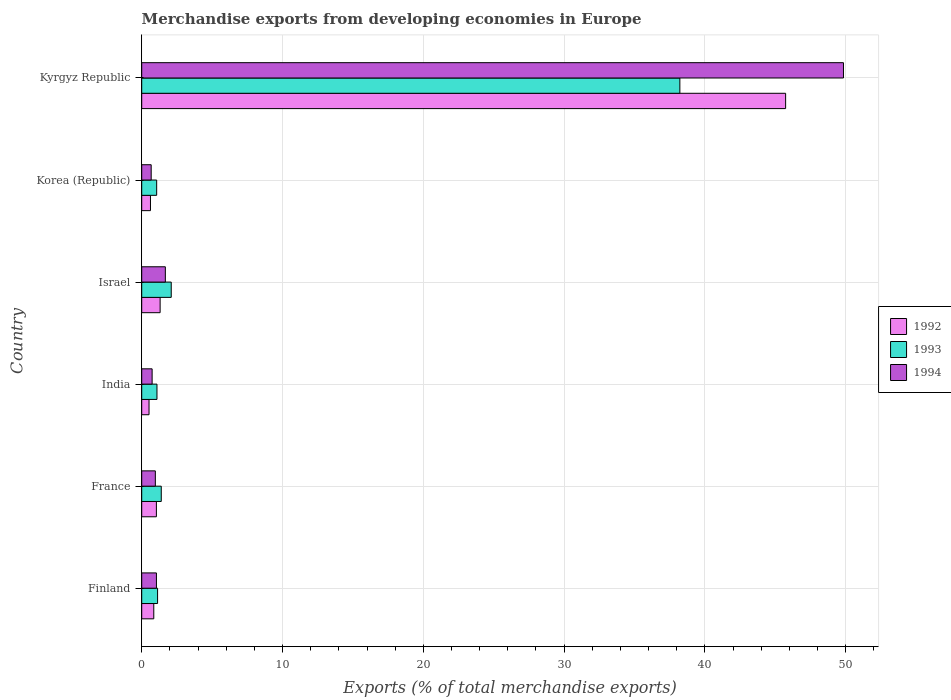How many groups of bars are there?
Offer a terse response. 6. How many bars are there on the 3rd tick from the top?
Your response must be concise. 3. How many bars are there on the 6th tick from the bottom?
Offer a very short reply. 3. What is the percentage of total merchandise exports in 1992 in Finland?
Offer a very short reply. 0.86. Across all countries, what is the maximum percentage of total merchandise exports in 1992?
Your answer should be very brief. 45.73. Across all countries, what is the minimum percentage of total merchandise exports in 1993?
Your answer should be very brief. 1.06. In which country was the percentage of total merchandise exports in 1993 maximum?
Provide a short and direct response. Kyrgyz Republic. What is the total percentage of total merchandise exports in 1992 in the graph?
Provide a short and direct response. 50.07. What is the difference between the percentage of total merchandise exports in 1994 in France and that in Israel?
Your answer should be compact. -0.71. What is the difference between the percentage of total merchandise exports in 1994 in India and the percentage of total merchandise exports in 1993 in Kyrgyz Republic?
Give a very brief answer. -37.48. What is the average percentage of total merchandise exports in 1994 per country?
Keep it short and to the point. 9.16. What is the difference between the percentage of total merchandise exports in 1993 and percentage of total merchandise exports in 1994 in Finland?
Make the answer very short. 0.08. What is the ratio of the percentage of total merchandise exports in 1992 in Finland to that in India?
Ensure brevity in your answer.  1.65. Is the difference between the percentage of total merchandise exports in 1993 in France and Israel greater than the difference between the percentage of total merchandise exports in 1994 in France and Israel?
Provide a succinct answer. Yes. What is the difference between the highest and the second highest percentage of total merchandise exports in 1994?
Your answer should be compact. 48.16. What is the difference between the highest and the lowest percentage of total merchandise exports in 1994?
Provide a succinct answer. 49.16. What does the 1st bar from the top in Kyrgyz Republic represents?
Offer a terse response. 1994. Are all the bars in the graph horizontal?
Ensure brevity in your answer.  Yes. What is the difference between two consecutive major ticks on the X-axis?
Keep it short and to the point. 10. Does the graph contain grids?
Keep it short and to the point. Yes. How many legend labels are there?
Ensure brevity in your answer.  3. How are the legend labels stacked?
Make the answer very short. Vertical. What is the title of the graph?
Your response must be concise. Merchandise exports from developing economies in Europe. Does "1963" appear as one of the legend labels in the graph?
Give a very brief answer. No. What is the label or title of the X-axis?
Keep it short and to the point. Exports (% of total merchandise exports). What is the label or title of the Y-axis?
Your response must be concise. Country. What is the Exports (% of total merchandise exports) in 1992 in Finland?
Offer a terse response. 0.86. What is the Exports (% of total merchandise exports) in 1993 in Finland?
Ensure brevity in your answer.  1.13. What is the Exports (% of total merchandise exports) in 1994 in Finland?
Offer a terse response. 1.05. What is the Exports (% of total merchandise exports) of 1992 in France?
Offer a terse response. 1.04. What is the Exports (% of total merchandise exports) of 1993 in France?
Offer a very short reply. 1.39. What is the Exports (% of total merchandise exports) of 1994 in France?
Give a very brief answer. 0.97. What is the Exports (% of total merchandise exports) of 1992 in India?
Your answer should be very brief. 0.52. What is the Exports (% of total merchandise exports) in 1993 in India?
Ensure brevity in your answer.  1.08. What is the Exports (% of total merchandise exports) of 1994 in India?
Make the answer very short. 0.74. What is the Exports (% of total merchandise exports) in 1992 in Israel?
Give a very brief answer. 1.31. What is the Exports (% of total merchandise exports) of 1993 in Israel?
Your response must be concise. 2.1. What is the Exports (% of total merchandise exports) in 1994 in Israel?
Provide a short and direct response. 1.68. What is the Exports (% of total merchandise exports) in 1992 in Korea (Republic)?
Offer a terse response. 0.62. What is the Exports (% of total merchandise exports) of 1993 in Korea (Republic)?
Ensure brevity in your answer.  1.06. What is the Exports (% of total merchandise exports) of 1994 in Korea (Republic)?
Ensure brevity in your answer.  0.67. What is the Exports (% of total merchandise exports) in 1992 in Kyrgyz Republic?
Keep it short and to the point. 45.73. What is the Exports (% of total merchandise exports) of 1993 in Kyrgyz Republic?
Make the answer very short. 38.22. What is the Exports (% of total merchandise exports) in 1994 in Kyrgyz Republic?
Provide a short and direct response. 49.84. Across all countries, what is the maximum Exports (% of total merchandise exports) of 1992?
Provide a succinct answer. 45.73. Across all countries, what is the maximum Exports (% of total merchandise exports) in 1993?
Offer a very short reply. 38.22. Across all countries, what is the maximum Exports (% of total merchandise exports) of 1994?
Ensure brevity in your answer.  49.84. Across all countries, what is the minimum Exports (% of total merchandise exports) in 1992?
Your response must be concise. 0.52. Across all countries, what is the minimum Exports (% of total merchandise exports) of 1993?
Give a very brief answer. 1.06. Across all countries, what is the minimum Exports (% of total merchandise exports) in 1994?
Your answer should be compact. 0.67. What is the total Exports (% of total merchandise exports) of 1992 in the graph?
Give a very brief answer. 50.07. What is the total Exports (% of total merchandise exports) of 1993 in the graph?
Give a very brief answer. 44.97. What is the total Exports (% of total merchandise exports) in 1994 in the graph?
Offer a very short reply. 54.94. What is the difference between the Exports (% of total merchandise exports) of 1992 in Finland and that in France?
Offer a very short reply. -0.19. What is the difference between the Exports (% of total merchandise exports) in 1993 in Finland and that in France?
Offer a terse response. -0.26. What is the difference between the Exports (% of total merchandise exports) in 1994 in Finland and that in France?
Make the answer very short. 0.08. What is the difference between the Exports (% of total merchandise exports) of 1992 in Finland and that in India?
Keep it short and to the point. 0.34. What is the difference between the Exports (% of total merchandise exports) of 1993 in Finland and that in India?
Your response must be concise. 0.04. What is the difference between the Exports (% of total merchandise exports) of 1994 in Finland and that in India?
Ensure brevity in your answer.  0.31. What is the difference between the Exports (% of total merchandise exports) in 1992 in Finland and that in Israel?
Provide a short and direct response. -0.45. What is the difference between the Exports (% of total merchandise exports) of 1993 in Finland and that in Israel?
Make the answer very short. -0.97. What is the difference between the Exports (% of total merchandise exports) of 1994 in Finland and that in Israel?
Ensure brevity in your answer.  -0.63. What is the difference between the Exports (% of total merchandise exports) of 1992 in Finland and that in Korea (Republic)?
Offer a very short reply. 0.24. What is the difference between the Exports (% of total merchandise exports) in 1993 in Finland and that in Korea (Republic)?
Your answer should be very brief. 0.07. What is the difference between the Exports (% of total merchandise exports) of 1994 in Finland and that in Korea (Republic)?
Offer a terse response. 0.37. What is the difference between the Exports (% of total merchandise exports) of 1992 in Finland and that in Kyrgyz Republic?
Provide a short and direct response. -44.87. What is the difference between the Exports (% of total merchandise exports) of 1993 in Finland and that in Kyrgyz Republic?
Provide a succinct answer. -37.09. What is the difference between the Exports (% of total merchandise exports) in 1994 in Finland and that in Kyrgyz Republic?
Keep it short and to the point. -48.79. What is the difference between the Exports (% of total merchandise exports) of 1992 in France and that in India?
Provide a short and direct response. 0.52. What is the difference between the Exports (% of total merchandise exports) in 1993 in France and that in India?
Make the answer very short. 0.31. What is the difference between the Exports (% of total merchandise exports) in 1994 in France and that in India?
Your response must be concise. 0.23. What is the difference between the Exports (% of total merchandise exports) in 1992 in France and that in Israel?
Your answer should be compact. -0.26. What is the difference between the Exports (% of total merchandise exports) in 1993 in France and that in Israel?
Give a very brief answer. -0.71. What is the difference between the Exports (% of total merchandise exports) in 1994 in France and that in Israel?
Your response must be concise. -0.71. What is the difference between the Exports (% of total merchandise exports) in 1992 in France and that in Korea (Republic)?
Your answer should be compact. 0.42. What is the difference between the Exports (% of total merchandise exports) of 1993 in France and that in Korea (Republic)?
Your answer should be compact. 0.33. What is the difference between the Exports (% of total merchandise exports) of 1994 in France and that in Korea (Republic)?
Provide a short and direct response. 0.3. What is the difference between the Exports (% of total merchandise exports) in 1992 in France and that in Kyrgyz Republic?
Your answer should be very brief. -44.69. What is the difference between the Exports (% of total merchandise exports) of 1993 in France and that in Kyrgyz Republic?
Provide a short and direct response. -36.83. What is the difference between the Exports (% of total merchandise exports) in 1994 in France and that in Kyrgyz Republic?
Keep it short and to the point. -48.87. What is the difference between the Exports (% of total merchandise exports) of 1992 in India and that in Israel?
Provide a short and direct response. -0.79. What is the difference between the Exports (% of total merchandise exports) in 1993 in India and that in Israel?
Give a very brief answer. -1.01. What is the difference between the Exports (% of total merchandise exports) of 1994 in India and that in Israel?
Your response must be concise. -0.94. What is the difference between the Exports (% of total merchandise exports) in 1992 in India and that in Korea (Republic)?
Offer a very short reply. -0.1. What is the difference between the Exports (% of total merchandise exports) in 1993 in India and that in Korea (Republic)?
Ensure brevity in your answer.  0.02. What is the difference between the Exports (% of total merchandise exports) of 1994 in India and that in Korea (Republic)?
Ensure brevity in your answer.  0.07. What is the difference between the Exports (% of total merchandise exports) of 1992 in India and that in Kyrgyz Republic?
Your response must be concise. -45.21. What is the difference between the Exports (% of total merchandise exports) of 1993 in India and that in Kyrgyz Republic?
Your answer should be very brief. -37.13. What is the difference between the Exports (% of total merchandise exports) in 1994 in India and that in Kyrgyz Republic?
Your answer should be compact. -49.1. What is the difference between the Exports (% of total merchandise exports) in 1992 in Israel and that in Korea (Republic)?
Your answer should be compact. 0.69. What is the difference between the Exports (% of total merchandise exports) of 1993 in Israel and that in Korea (Republic)?
Provide a succinct answer. 1.03. What is the difference between the Exports (% of total merchandise exports) of 1994 in Israel and that in Korea (Republic)?
Provide a short and direct response. 1.01. What is the difference between the Exports (% of total merchandise exports) in 1992 in Israel and that in Kyrgyz Republic?
Give a very brief answer. -44.42. What is the difference between the Exports (% of total merchandise exports) in 1993 in Israel and that in Kyrgyz Republic?
Offer a very short reply. -36.12. What is the difference between the Exports (% of total merchandise exports) in 1994 in Israel and that in Kyrgyz Republic?
Give a very brief answer. -48.16. What is the difference between the Exports (% of total merchandise exports) in 1992 in Korea (Republic) and that in Kyrgyz Republic?
Your answer should be compact. -45.11. What is the difference between the Exports (% of total merchandise exports) of 1993 in Korea (Republic) and that in Kyrgyz Republic?
Ensure brevity in your answer.  -37.16. What is the difference between the Exports (% of total merchandise exports) in 1994 in Korea (Republic) and that in Kyrgyz Republic?
Provide a succinct answer. -49.16. What is the difference between the Exports (% of total merchandise exports) in 1992 in Finland and the Exports (% of total merchandise exports) in 1993 in France?
Make the answer very short. -0.53. What is the difference between the Exports (% of total merchandise exports) in 1992 in Finland and the Exports (% of total merchandise exports) in 1994 in France?
Your answer should be very brief. -0.11. What is the difference between the Exports (% of total merchandise exports) in 1993 in Finland and the Exports (% of total merchandise exports) in 1994 in France?
Offer a very short reply. 0.16. What is the difference between the Exports (% of total merchandise exports) in 1992 in Finland and the Exports (% of total merchandise exports) in 1993 in India?
Keep it short and to the point. -0.23. What is the difference between the Exports (% of total merchandise exports) of 1992 in Finland and the Exports (% of total merchandise exports) of 1994 in India?
Give a very brief answer. 0.12. What is the difference between the Exports (% of total merchandise exports) of 1993 in Finland and the Exports (% of total merchandise exports) of 1994 in India?
Keep it short and to the point. 0.39. What is the difference between the Exports (% of total merchandise exports) of 1992 in Finland and the Exports (% of total merchandise exports) of 1993 in Israel?
Give a very brief answer. -1.24. What is the difference between the Exports (% of total merchandise exports) in 1992 in Finland and the Exports (% of total merchandise exports) in 1994 in Israel?
Your answer should be compact. -0.82. What is the difference between the Exports (% of total merchandise exports) of 1993 in Finland and the Exports (% of total merchandise exports) of 1994 in Israel?
Offer a terse response. -0.55. What is the difference between the Exports (% of total merchandise exports) of 1992 in Finland and the Exports (% of total merchandise exports) of 1993 in Korea (Republic)?
Offer a terse response. -0.2. What is the difference between the Exports (% of total merchandise exports) of 1992 in Finland and the Exports (% of total merchandise exports) of 1994 in Korea (Republic)?
Ensure brevity in your answer.  0.18. What is the difference between the Exports (% of total merchandise exports) in 1993 in Finland and the Exports (% of total merchandise exports) in 1994 in Korea (Republic)?
Offer a very short reply. 0.45. What is the difference between the Exports (% of total merchandise exports) of 1992 in Finland and the Exports (% of total merchandise exports) of 1993 in Kyrgyz Republic?
Give a very brief answer. -37.36. What is the difference between the Exports (% of total merchandise exports) of 1992 in Finland and the Exports (% of total merchandise exports) of 1994 in Kyrgyz Republic?
Offer a terse response. -48.98. What is the difference between the Exports (% of total merchandise exports) of 1993 in Finland and the Exports (% of total merchandise exports) of 1994 in Kyrgyz Republic?
Provide a short and direct response. -48.71. What is the difference between the Exports (% of total merchandise exports) in 1992 in France and the Exports (% of total merchandise exports) in 1993 in India?
Give a very brief answer. -0.04. What is the difference between the Exports (% of total merchandise exports) of 1992 in France and the Exports (% of total merchandise exports) of 1994 in India?
Give a very brief answer. 0.3. What is the difference between the Exports (% of total merchandise exports) of 1993 in France and the Exports (% of total merchandise exports) of 1994 in India?
Provide a short and direct response. 0.65. What is the difference between the Exports (% of total merchandise exports) in 1992 in France and the Exports (% of total merchandise exports) in 1993 in Israel?
Your answer should be very brief. -1.05. What is the difference between the Exports (% of total merchandise exports) of 1992 in France and the Exports (% of total merchandise exports) of 1994 in Israel?
Give a very brief answer. -0.64. What is the difference between the Exports (% of total merchandise exports) of 1993 in France and the Exports (% of total merchandise exports) of 1994 in Israel?
Make the answer very short. -0.29. What is the difference between the Exports (% of total merchandise exports) of 1992 in France and the Exports (% of total merchandise exports) of 1993 in Korea (Republic)?
Your answer should be very brief. -0.02. What is the difference between the Exports (% of total merchandise exports) of 1992 in France and the Exports (% of total merchandise exports) of 1994 in Korea (Republic)?
Provide a succinct answer. 0.37. What is the difference between the Exports (% of total merchandise exports) of 1993 in France and the Exports (% of total merchandise exports) of 1994 in Korea (Republic)?
Your answer should be very brief. 0.72. What is the difference between the Exports (% of total merchandise exports) in 1992 in France and the Exports (% of total merchandise exports) in 1993 in Kyrgyz Republic?
Provide a short and direct response. -37.18. What is the difference between the Exports (% of total merchandise exports) in 1992 in France and the Exports (% of total merchandise exports) in 1994 in Kyrgyz Republic?
Your response must be concise. -48.79. What is the difference between the Exports (% of total merchandise exports) in 1993 in France and the Exports (% of total merchandise exports) in 1994 in Kyrgyz Republic?
Your response must be concise. -48.45. What is the difference between the Exports (% of total merchandise exports) of 1992 in India and the Exports (% of total merchandise exports) of 1993 in Israel?
Provide a short and direct response. -1.58. What is the difference between the Exports (% of total merchandise exports) of 1992 in India and the Exports (% of total merchandise exports) of 1994 in Israel?
Keep it short and to the point. -1.16. What is the difference between the Exports (% of total merchandise exports) of 1993 in India and the Exports (% of total merchandise exports) of 1994 in Israel?
Ensure brevity in your answer.  -0.59. What is the difference between the Exports (% of total merchandise exports) in 1992 in India and the Exports (% of total merchandise exports) in 1993 in Korea (Republic)?
Your response must be concise. -0.54. What is the difference between the Exports (% of total merchandise exports) of 1992 in India and the Exports (% of total merchandise exports) of 1994 in Korea (Republic)?
Keep it short and to the point. -0.15. What is the difference between the Exports (% of total merchandise exports) in 1993 in India and the Exports (% of total merchandise exports) in 1994 in Korea (Republic)?
Keep it short and to the point. 0.41. What is the difference between the Exports (% of total merchandise exports) of 1992 in India and the Exports (% of total merchandise exports) of 1993 in Kyrgyz Republic?
Your answer should be very brief. -37.7. What is the difference between the Exports (% of total merchandise exports) of 1992 in India and the Exports (% of total merchandise exports) of 1994 in Kyrgyz Republic?
Make the answer very short. -49.32. What is the difference between the Exports (% of total merchandise exports) of 1993 in India and the Exports (% of total merchandise exports) of 1994 in Kyrgyz Republic?
Give a very brief answer. -48.75. What is the difference between the Exports (% of total merchandise exports) in 1992 in Israel and the Exports (% of total merchandise exports) in 1993 in Korea (Republic)?
Provide a succinct answer. 0.25. What is the difference between the Exports (% of total merchandise exports) of 1992 in Israel and the Exports (% of total merchandise exports) of 1994 in Korea (Republic)?
Provide a short and direct response. 0.63. What is the difference between the Exports (% of total merchandise exports) of 1993 in Israel and the Exports (% of total merchandise exports) of 1994 in Korea (Republic)?
Your answer should be very brief. 1.42. What is the difference between the Exports (% of total merchandise exports) in 1992 in Israel and the Exports (% of total merchandise exports) in 1993 in Kyrgyz Republic?
Your answer should be compact. -36.91. What is the difference between the Exports (% of total merchandise exports) in 1992 in Israel and the Exports (% of total merchandise exports) in 1994 in Kyrgyz Republic?
Your answer should be compact. -48.53. What is the difference between the Exports (% of total merchandise exports) of 1993 in Israel and the Exports (% of total merchandise exports) of 1994 in Kyrgyz Republic?
Your answer should be very brief. -47.74. What is the difference between the Exports (% of total merchandise exports) of 1992 in Korea (Republic) and the Exports (% of total merchandise exports) of 1993 in Kyrgyz Republic?
Give a very brief answer. -37.6. What is the difference between the Exports (% of total merchandise exports) of 1992 in Korea (Republic) and the Exports (% of total merchandise exports) of 1994 in Kyrgyz Republic?
Your answer should be compact. -49.22. What is the difference between the Exports (% of total merchandise exports) of 1993 in Korea (Republic) and the Exports (% of total merchandise exports) of 1994 in Kyrgyz Republic?
Give a very brief answer. -48.77. What is the average Exports (% of total merchandise exports) in 1992 per country?
Your response must be concise. 8.35. What is the average Exports (% of total merchandise exports) in 1993 per country?
Ensure brevity in your answer.  7.5. What is the average Exports (% of total merchandise exports) of 1994 per country?
Your answer should be very brief. 9.16. What is the difference between the Exports (% of total merchandise exports) in 1992 and Exports (% of total merchandise exports) in 1993 in Finland?
Your response must be concise. -0.27. What is the difference between the Exports (% of total merchandise exports) of 1992 and Exports (% of total merchandise exports) of 1994 in Finland?
Offer a very short reply. -0.19. What is the difference between the Exports (% of total merchandise exports) in 1993 and Exports (% of total merchandise exports) in 1994 in Finland?
Provide a short and direct response. 0.08. What is the difference between the Exports (% of total merchandise exports) of 1992 and Exports (% of total merchandise exports) of 1993 in France?
Offer a terse response. -0.35. What is the difference between the Exports (% of total merchandise exports) in 1992 and Exports (% of total merchandise exports) in 1994 in France?
Offer a very short reply. 0.07. What is the difference between the Exports (% of total merchandise exports) of 1993 and Exports (% of total merchandise exports) of 1994 in France?
Your answer should be compact. 0.42. What is the difference between the Exports (% of total merchandise exports) of 1992 and Exports (% of total merchandise exports) of 1993 in India?
Your answer should be very brief. -0.56. What is the difference between the Exports (% of total merchandise exports) in 1992 and Exports (% of total merchandise exports) in 1994 in India?
Keep it short and to the point. -0.22. What is the difference between the Exports (% of total merchandise exports) of 1993 and Exports (% of total merchandise exports) of 1994 in India?
Offer a terse response. 0.34. What is the difference between the Exports (% of total merchandise exports) in 1992 and Exports (% of total merchandise exports) in 1993 in Israel?
Your answer should be very brief. -0.79. What is the difference between the Exports (% of total merchandise exports) in 1992 and Exports (% of total merchandise exports) in 1994 in Israel?
Your answer should be very brief. -0.37. What is the difference between the Exports (% of total merchandise exports) in 1993 and Exports (% of total merchandise exports) in 1994 in Israel?
Offer a terse response. 0.42. What is the difference between the Exports (% of total merchandise exports) in 1992 and Exports (% of total merchandise exports) in 1993 in Korea (Republic)?
Offer a very short reply. -0.44. What is the difference between the Exports (% of total merchandise exports) of 1992 and Exports (% of total merchandise exports) of 1994 in Korea (Republic)?
Provide a succinct answer. -0.05. What is the difference between the Exports (% of total merchandise exports) of 1993 and Exports (% of total merchandise exports) of 1994 in Korea (Republic)?
Give a very brief answer. 0.39. What is the difference between the Exports (% of total merchandise exports) of 1992 and Exports (% of total merchandise exports) of 1993 in Kyrgyz Republic?
Give a very brief answer. 7.51. What is the difference between the Exports (% of total merchandise exports) in 1992 and Exports (% of total merchandise exports) in 1994 in Kyrgyz Republic?
Offer a terse response. -4.11. What is the difference between the Exports (% of total merchandise exports) in 1993 and Exports (% of total merchandise exports) in 1994 in Kyrgyz Republic?
Keep it short and to the point. -11.62. What is the ratio of the Exports (% of total merchandise exports) in 1992 in Finland to that in France?
Make the answer very short. 0.82. What is the ratio of the Exports (% of total merchandise exports) of 1993 in Finland to that in France?
Keep it short and to the point. 0.81. What is the ratio of the Exports (% of total merchandise exports) of 1994 in Finland to that in France?
Provide a succinct answer. 1.08. What is the ratio of the Exports (% of total merchandise exports) in 1992 in Finland to that in India?
Provide a short and direct response. 1.65. What is the ratio of the Exports (% of total merchandise exports) of 1993 in Finland to that in India?
Make the answer very short. 1.04. What is the ratio of the Exports (% of total merchandise exports) of 1994 in Finland to that in India?
Ensure brevity in your answer.  1.41. What is the ratio of the Exports (% of total merchandise exports) in 1992 in Finland to that in Israel?
Ensure brevity in your answer.  0.66. What is the ratio of the Exports (% of total merchandise exports) of 1993 in Finland to that in Israel?
Provide a succinct answer. 0.54. What is the ratio of the Exports (% of total merchandise exports) in 1994 in Finland to that in Israel?
Give a very brief answer. 0.62. What is the ratio of the Exports (% of total merchandise exports) of 1992 in Finland to that in Korea (Republic)?
Provide a short and direct response. 1.38. What is the ratio of the Exports (% of total merchandise exports) of 1993 in Finland to that in Korea (Republic)?
Provide a short and direct response. 1.06. What is the ratio of the Exports (% of total merchandise exports) in 1994 in Finland to that in Korea (Republic)?
Offer a very short reply. 1.55. What is the ratio of the Exports (% of total merchandise exports) in 1992 in Finland to that in Kyrgyz Republic?
Provide a succinct answer. 0.02. What is the ratio of the Exports (% of total merchandise exports) of 1993 in Finland to that in Kyrgyz Republic?
Your response must be concise. 0.03. What is the ratio of the Exports (% of total merchandise exports) in 1994 in Finland to that in Kyrgyz Republic?
Your response must be concise. 0.02. What is the ratio of the Exports (% of total merchandise exports) in 1992 in France to that in India?
Give a very brief answer. 2.01. What is the ratio of the Exports (% of total merchandise exports) of 1993 in France to that in India?
Offer a very short reply. 1.28. What is the ratio of the Exports (% of total merchandise exports) in 1994 in France to that in India?
Your response must be concise. 1.31. What is the ratio of the Exports (% of total merchandise exports) of 1992 in France to that in Israel?
Your response must be concise. 0.8. What is the ratio of the Exports (% of total merchandise exports) of 1993 in France to that in Israel?
Make the answer very short. 0.66. What is the ratio of the Exports (% of total merchandise exports) of 1994 in France to that in Israel?
Make the answer very short. 0.58. What is the ratio of the Exports (% of total merchandise exports) of 1992 in France to that in Korea (Republic)?
Ensure brevity in your answer.  1.68. What is the ratio of the Exports (% of total merchandise exports) in 1993 in France to that in Korea (Republic)?
Make the answer very short. 1.31. What is the ratio of the Exports (% of total merchandise exports) of 1994 in France to that in Korea (Republic)?
Provide a succinct answer. 1.44. What is the ratio of the Exports (% of total merchandise exports) of 1992 in France to that in Kyrgyz Republic?
Provide a short and direct response. 0.02. What is the ratio of the Exports (% of total merchandise exports) of 1993 in France to that in Kyrgyz Republic?
Offer a terse response. 0.04. What is the ratio of the Exports (% of total merchandise exports) of 1994 in France to that in Kyrgyz Republic?
Offer a very short reply. 0.02. What is the ratio of the Exports (% of total merchandise exports) of 1992 in India to that in Israel?
Your response must be concise. 0.4. What is the ratio of the Exports (% of total merchandise exports) in 1993 in India to that in Israel?
Make the answer very short. 0.52. What is the ratio of the Exports (% of total merchandise exports) of 1994 in India to that in Israel?
Provide a short and direct response. 0.44. What is the ratio of the Exports (% of total merchandise exports) of 1992 in India to that in Korea (Republic)?
Keep it short and to the point. 0.84. What is the ratio of the Exports (% of total merchandise exports) of 1993 in India to that in Korea (Republic)?
Your answer should be compact. 1.02. What is the ratio of the Exports (% of total merchandise exports) in 1994 in India to that in Korea (Republic)?
Make the answer very short. 1.1. What is the ratio of the Exports (% of total merchandise exports) in 1992 in India to that in Kyrgyz Republic?
Offer a terse response. 0.01. What is the ratio of the Exports (% of total merchandise exports) of 1993 in India to that in Kyrgyz Republic?
Ensure brevity in your answer.  0.03. What is the ratio of the Exports (% of total merchandise exports) in 1994 in India to that in Kyrgyz Republic?
Make the answer very short. 0.01. What is the ratio of the Exports (% of total merchandise exports) of 1992 in Israel to that in Korea (Republic)?
Offer a very short reply. 2.11. What is the ratio of the Exports (% of total merchandise exports) of 1993 in Israel to that in Korea (Republic)?
Make the answer very short. 1.97. What is the ratio of the Exports (% of total merchandise exports) in 1994 in Israel to that in Korea (Republic)?
Offer a terse response. 2.49. What is the ratio of the Exports (% of total merchandise exports) in 1992 in Israel to that in Kyrgyz Republic?
Give a very brief answer. 0.03. What is the ratio of the Exports (% of total merchandise exports) of 1993 in Israel to that in Kyrgyz Republic?
Keep it short and to the point. 0.05. What is the ratio of the Exports (% of total merchandise exports) of 1994 in Israel to that in Kyrgyz Republic?
Ensure brevity in your answer.  0.03. What is the ratio of the Exports (% of total merchandise exports) in 1992 in Korea (Republic) to that in Kyrgyz Republic?
Your answer should be very brief. 0.01. What is the ratio of the Exports (% of total merchandise exports) in 1993 in Korea (Republic) to that in Kyrgyz Republic?
Keep it short and to the point. 0.03. What is the ratio of the Exports (% of total merchandise exports) in 1994 in Korea (Republic) to that in Kyrgyz Republic?
Provide a short and direct response. 0.01. What is the difference between the highest and the second highest Exports (% of total merchandise exports) of 1992?
Make the answer very short. 44.42. What is the difference between the highest and the second highest Exports (% of total merchandise exports) of 1993?
Your response must be concise. 36.12. What is the difference between the highest and the second highest Exports (% of total merchandise exports) of 1994?
Give a very brief answer. 48.16. What is the difference between the highest and the lowest Exports (% of total merchandise exports) in 1992?
Offer a very short reply. 45.21. What is the difference between the highest and the lowest Exports (% of total merchandise exports) of 1993?
Keep it short and to the point. 37.16. What is the difference between the highest and the lowest Exports (% of total merchandise exports) in 1994?
Your answer should be very brief. 49.16. 